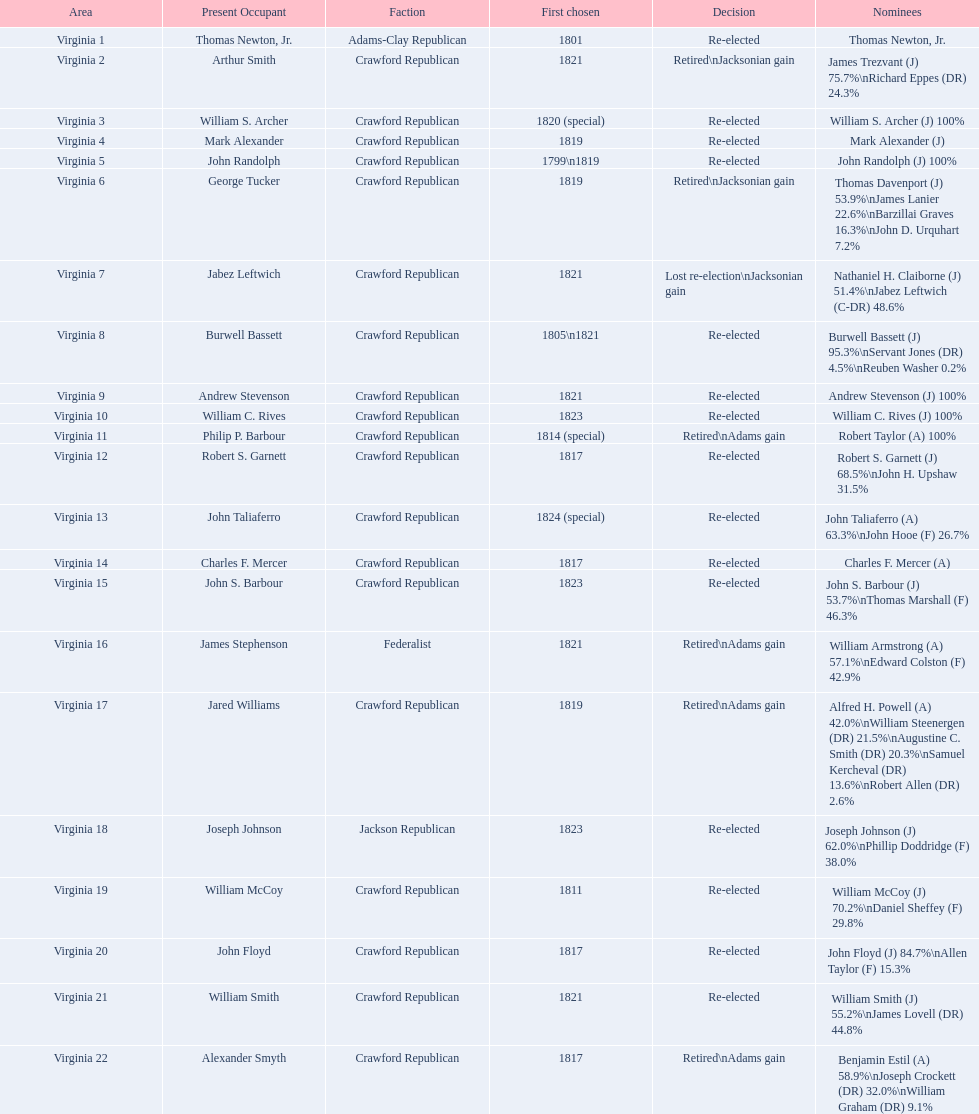Would you mind parsing the complete table? {'header': ['Area', 'Present Occupant', 'Faction', 'First chosen', 'Decision', 'Nominees'], 'rows': [['Virginia 1', 'Thomas Newton, Jr.', 'Adams-Clay Republican', '1801', 'Re-elected', 'Thomas Newton, Jr.'], ['Virginia 2', 'Arthur Smith', 'Crawford Republican', '1821', 'Retired\\nJacksonian gain', 'James Trezvant (J) 75.7%\\nRichard Eppes (DR) 24.3%'], ['Virginia 3', 'William S. Archer', 'Crawford Republican', '1820 (special)', 'Re-elected', 'William S. Archer (J) 100%'], ['Virginia 4', 'Mark Alexander', 'Crawford Republican', '1819', 'Re-elected', 'Mark Alexander (J)'], ['Virginia 5', 'John Randolph', 'Crawford Republican', '1799\\n1819', 'Re-elected', 'John Randolph (J) 100%'], ['Virginia 6', 'George Tucker', 'Crawford Republican', '1819', 'Retired\\nJacksonian gain', 'Thomas Davenport (J) 53.9%\\nJames Lanier 22.6%\\nBarzillai Graves 16.3%\\nJohn D. Urquhart 7.2%'], ['Virginia 7', 'Jabez Leftwich', 'Crawford Republican', '1821', 'Lost re-election\\nJacksonian gain', 'Nathaniel H. Claiborne (J) 51.4%\\nJabez Leftwich (C-DR) 48.6%'], ['Virginia 8', 'Burwell Bassett', 'Crawford Republican', '1805\\n1821', 'Re-elected', 'Burwell Bassett (J) 95.3%\\nServant Jones (DR) 4.5%\\nReuben Washer 0.2%'], ['Virginia 9', 'Andrew Stevenson', 'Crawford Republican', '1821', 'Re-elected', 'Andrew Stevenson (J) 100%'], ['Virginia 10', 'William C. Rives', 'Crawford Republican', '1823', 'Re-elected', 'William C. Rives (J) 100%'], ['Virginia 11', 'Philip P. Barbour', 'Crawford Republican', '1814 (special)', 'Retired\\nAdams gain', 'Robert Taylor (A) 100%'], ['Virginia 12', 'Robert S. Garnett', 'Crawford Republican', '1817', 'Re-elected', 'Robert S. Garnett (J) 68.5%\\nJohn H. Upshaw 31.5%'], ['Virginia 13', 'John Taliaferro', 'Crawford Republican', '1824 (special)', 'Re-elected', 'John Taliaferro (A) 63.3%\\nJohn Hooe (F) 26.7%'], ['Virginia 14', 'Charles F. Mercer', 'Crawford Republican', '1817', 'Re-elected', 'Charles F. Mercer (A)'], ['Virginia 15', 'John S. Barbour', 'Crawford Republican', '1823', 'Re-elected', 'John S. Barbour (J) 53.7%\\nThomas Marshall (F) 46.3%'], ['Virginia 16', 'James Stephenson', 'Federalist', '1821', 'Retired\\nAdams gain', 'William Armstrong (A) 57.1%\\nEdward Colston (F) 42.9%'], ['Virginia 17', 'Jared Williams', 'Crawford Republican', '1819', 'Retired\\nAdams gain', 'Alfred H. Powell (A) 42.0%\\nWilliam Steenergen (DR) 21.5%\\nAugustine C. Smith (DR) 20.3%\\nSamuel Kercheval (DR) 13.6%\\nRobert Allen (DR) 2.6%'], ['Virginia 18', 'Joseph Johnson', 'Jackson Republican', '1823', 'Re-elected', 'Joseph Johnson (J) 62.0%\\nPhillip Doddridge (F) 38.0%'], ['Virginia 19', 'William McCoy', 'Crawford Republican', '1811', 'Re-elected', 'William McCoy (J) 70.2%\\nDaniel Sheffey (F) 29.8%'], ['Virginia 20', 'John Floyd', 'Crawford Republican', '1817', 'Re-elected', 'John Floyd (J) 84.7%\\nAllen Taylor (F) 15.3%'], ['Virginia 21', 'William Smith', 'Crawford Republican', '1821', 'Re-elected', 'William Smith (J) 55.2%\\nJames Lovell (DR) 44.8%'], ['Virginia 22', 'Alexander Smyth', 'Crawford Republican', '1817', 'Retired\\nAdams gain', 'Benjamin Estil (A) 58.9%\\nJoseph Crockett (DR) 32.0%\\nWilliam Graham (DR) 9.1%']]} How many candidates were there for virginia 17 district? 5. 